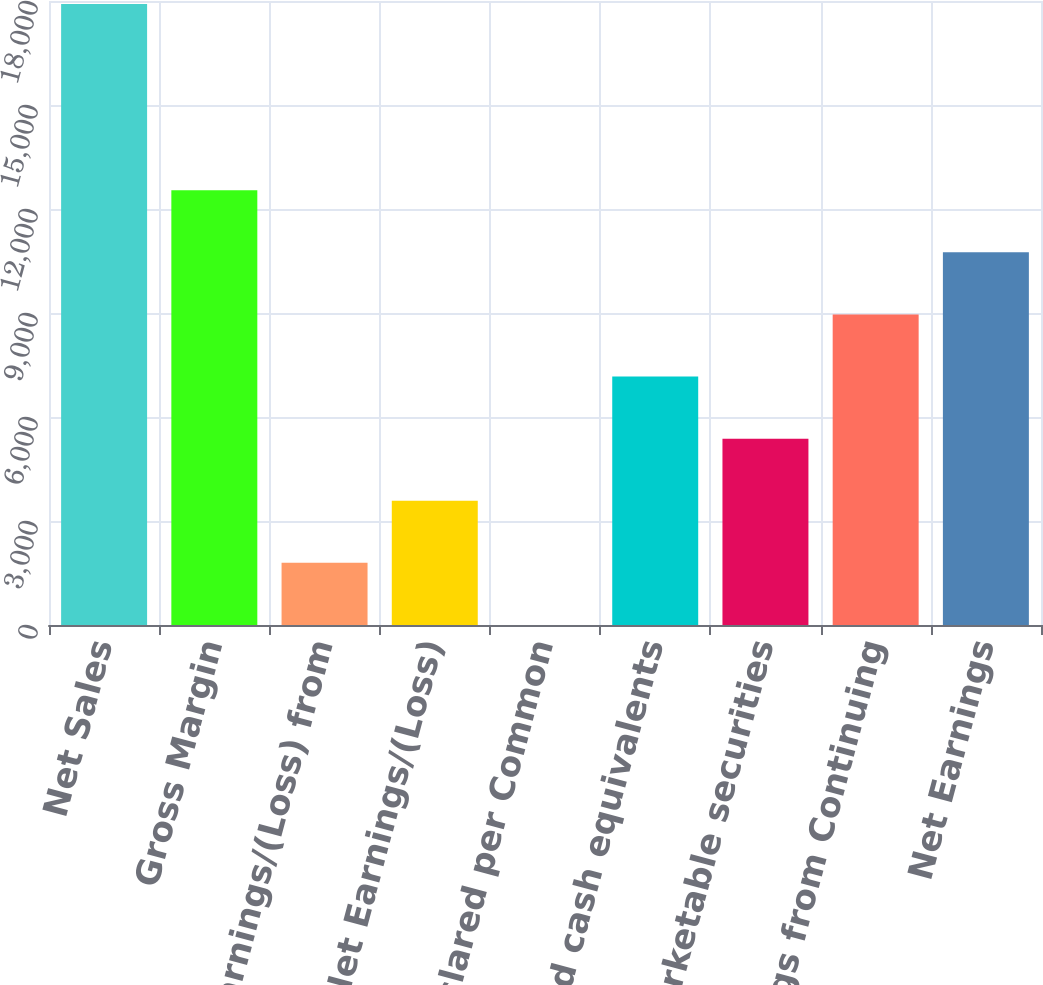<chart> <loc_0><loc_0><loc_500><loc_500><bar_chart><fcel>Net Sales<fcel>Gross Margin<fcel>Earnings/(Loss) from<fcel>Net Earnings/(Loss)<fcel>Dividends declared per Common<fcel>Cash and cash equivalents<fcel>Marketable securities<fcel>Earnings from Continuing<fcel>Net Earnings<nl><fcel>17914<fcel>12540.1<fcel>1792.41<fcel>3583.7<fcel>1.12<fcel>7166.28<fcel>5374.99<fcel>8957.57<fcel>10748.9<nl></chart> 